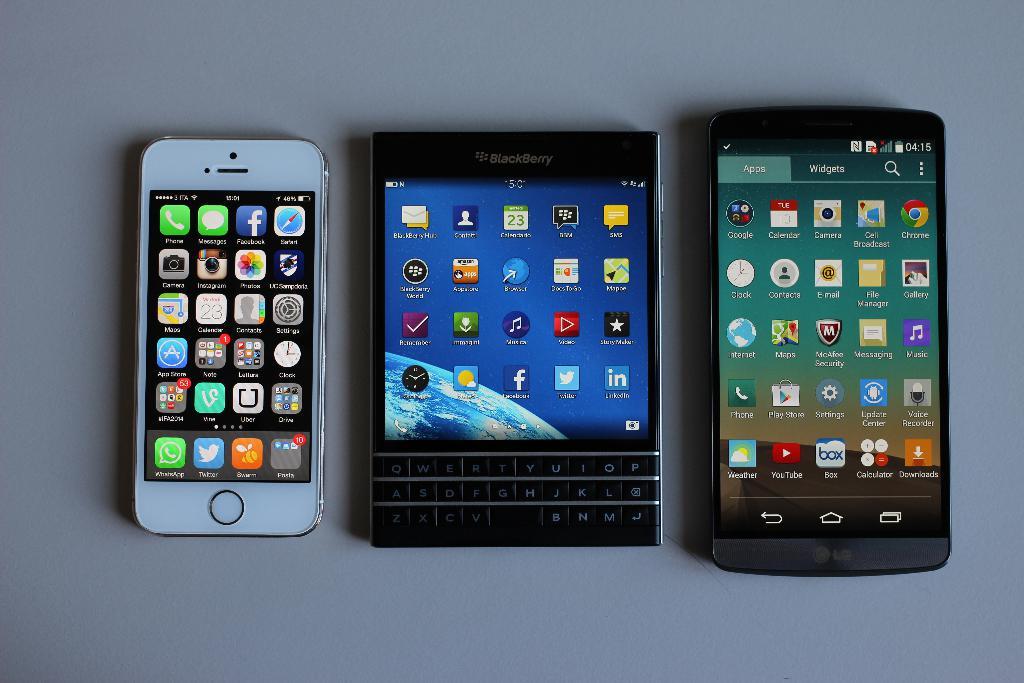What is the brand of the phone in the middle?
Make the answer very short. Blackberry. 